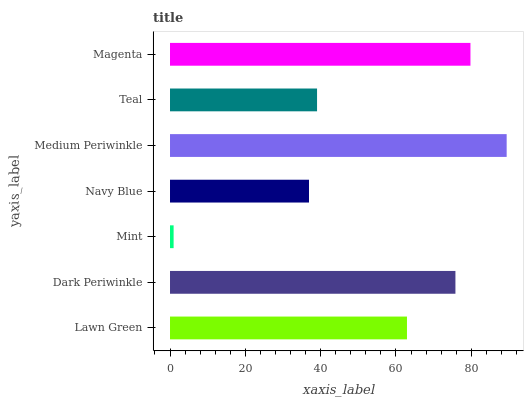Is Mint the minimum?
Answer yes or no. Yes. Is Medium Periwinkle the maximum?
Answer yes or no. Yes. Is Dark Periwinkle the minimum?
Answer yes or no. No. Is Dark Periwinkle the maximum?
Answer yes or no. No. Is Dark Periwinkle greater than Lawn Green?
Answer yes or no. Yes. Is Lawn Green less than Dark Periwinkle?
Answer yes or no. Yes. Is Lawn Green greater than Dark Periwinkle?
Answer yes or no. No. Is Dark Periwinkle less than Lawn Green?
Answer yes or no. No. Is Lawn Green the high median?
Answer yes or no. Yes. Is Lawn Green the low median?
Answer yes or no. Yes. Is Magenta the high median?
Answer yes or no. No. Is Medium Periwinkle the low median?
Answer yes or no. No. 